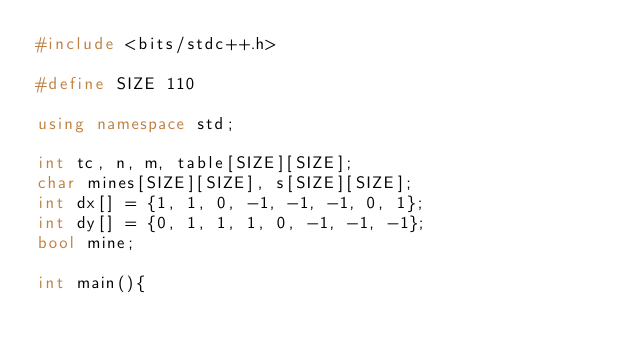<code> <loc_0><loc_0><loc_500><loc_500><_C++_>#include <bits/stdc++.h>

#define SIZE 110

using namespace std;

int tc, n, m, table[SIZE][SIZE];
char mines[SIZE][SIZE], s[SIZE][SIZE];
int dx[] = {1, 1, 0, -1, -1, -1, 0, 1};
int dy[] = {0, 1, 1, 1, 0, -1, -1, -1};
bool mine;

int main(){</code> 